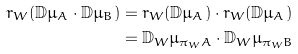<formula> <loc_0><loc_0><loc_500><loc_500>r _ { W } ( \mathbb { D } \mu _ { A } \cdot \mathbb { D } \mu _ { B } ) & = r _ { W } ( \mathbb { D } \mu _ { A } ) \cdot r _ { W } ( \mathbb { D } \mu _ { A } ) \\ & = \mathbb { D } _ { W } \mu _ { \pi _ { W } A } \cdot \mathbb { D } _ { W } \mu _ { \pi _ { W } B }</formula> 